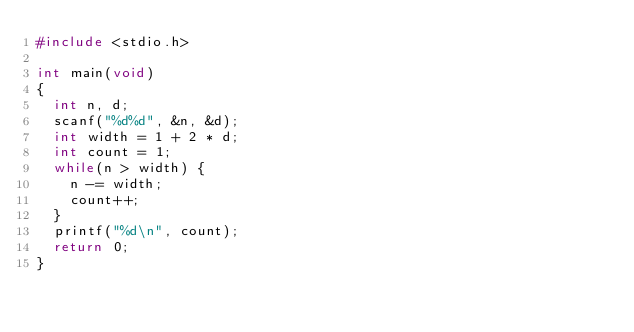<code> <loc_0><loc_0><loc_500><loc_500><_C_>#include <stdio.h>

int main(void)
{
  int n, d;
  scanf("%d%d", &n, &d);
  int width = 1 + 2 * d;
  int count = 1;
  while(n > width) {
    n -= width;
    count++;
  }
  printf("%d\n", count);
  return 0;
}
</code> 